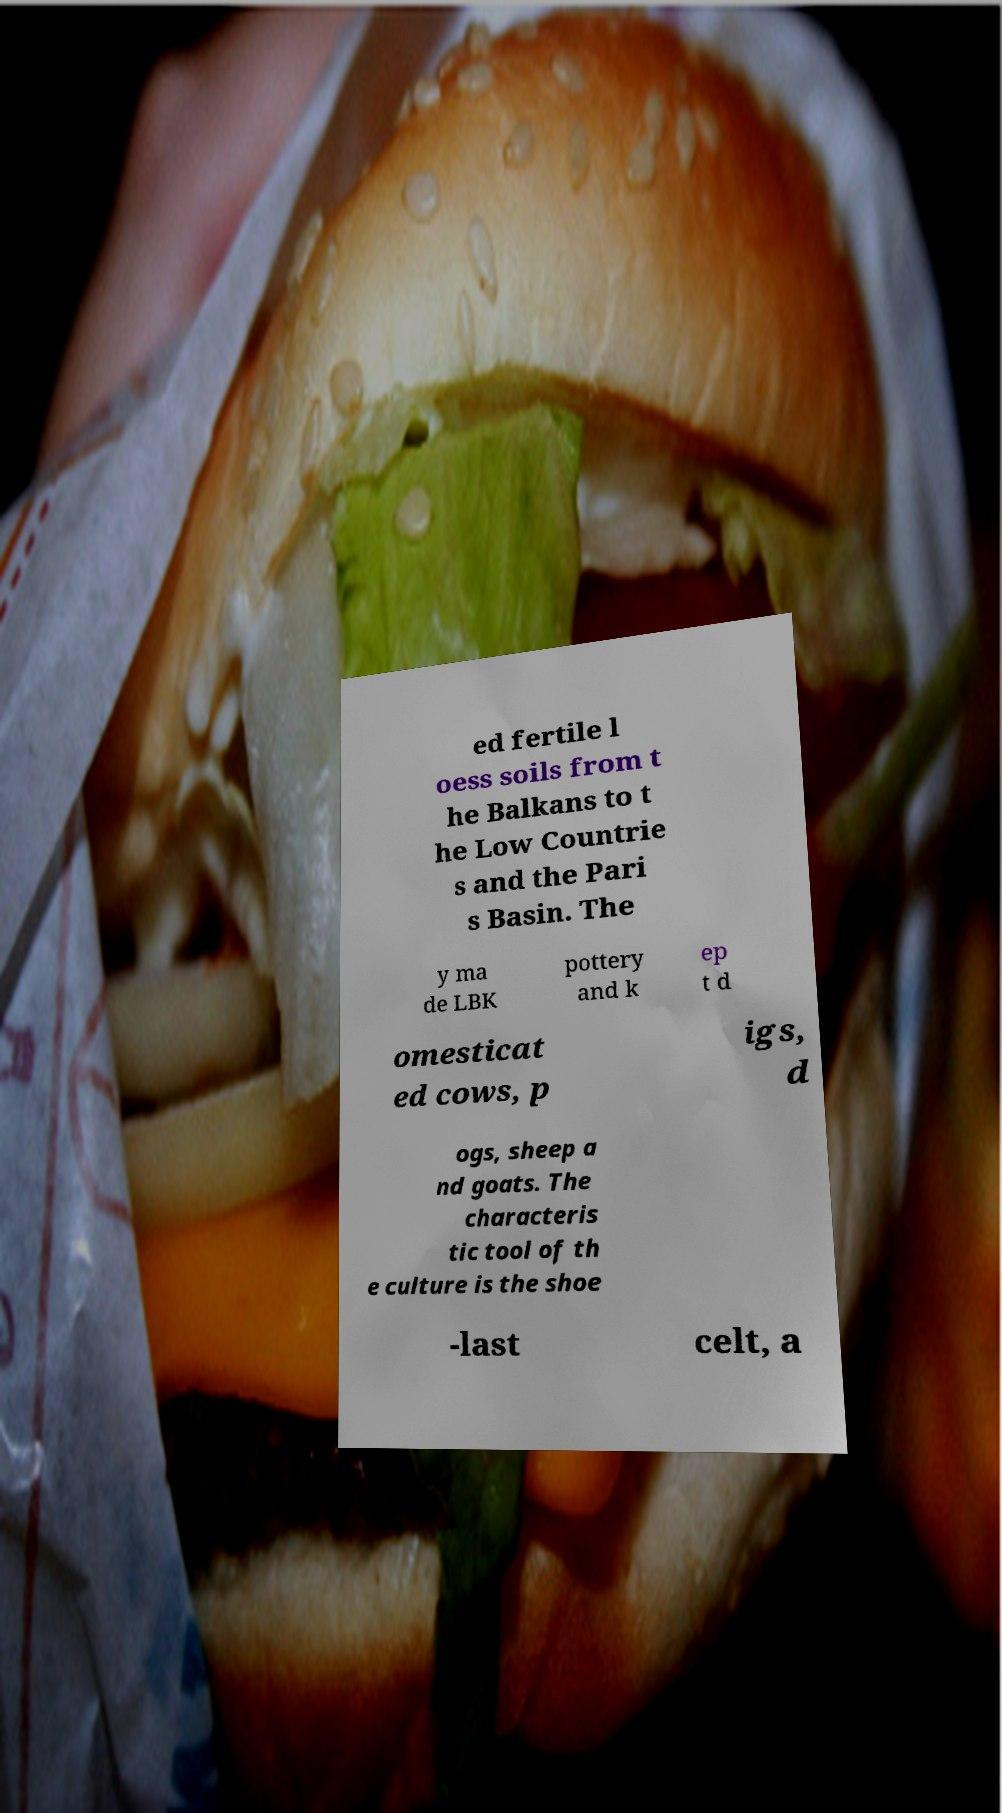There's text embedded in this image that I need extracted. Can you transcribe it verbatim? ed fertile l oess soils from t he Balkans to t he Low Countrie s and the Pari s Basin. The y ma de LBK pottery and k ep t d omesticat ed cows, p igs, d ogs, sheep a nd goats. The characteris tic tool of th e culture is the shoe -last celt, a 